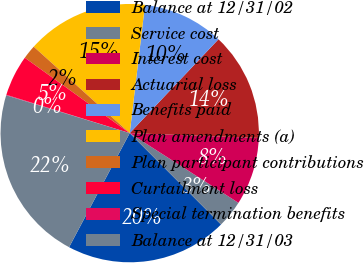Convert chart to OTSL. <chart><loc_0><loc_0><loc_500><loc_500><pie_chart><fcel>Balance at 12/31/02<fcel>Service cost<fcel>Interest cost<fcel>Actuarial loss<fcel>Benefits paid<fcel>Plan amendments (a)<fcel>Plan participant contributions<fcel>Curtailment loss<fcel>Special termination benefits<fcel>Balance at 12/31/03<nl><fcel>20.27%<fcel>3.43%<fcel>8.48%<fcel>13.54%<fcel>10.17%<fcel>15.22%<fcel>1.75%<fcel>5.12%<fcel>0.07%<fcel>21.95%<nl></chart> 